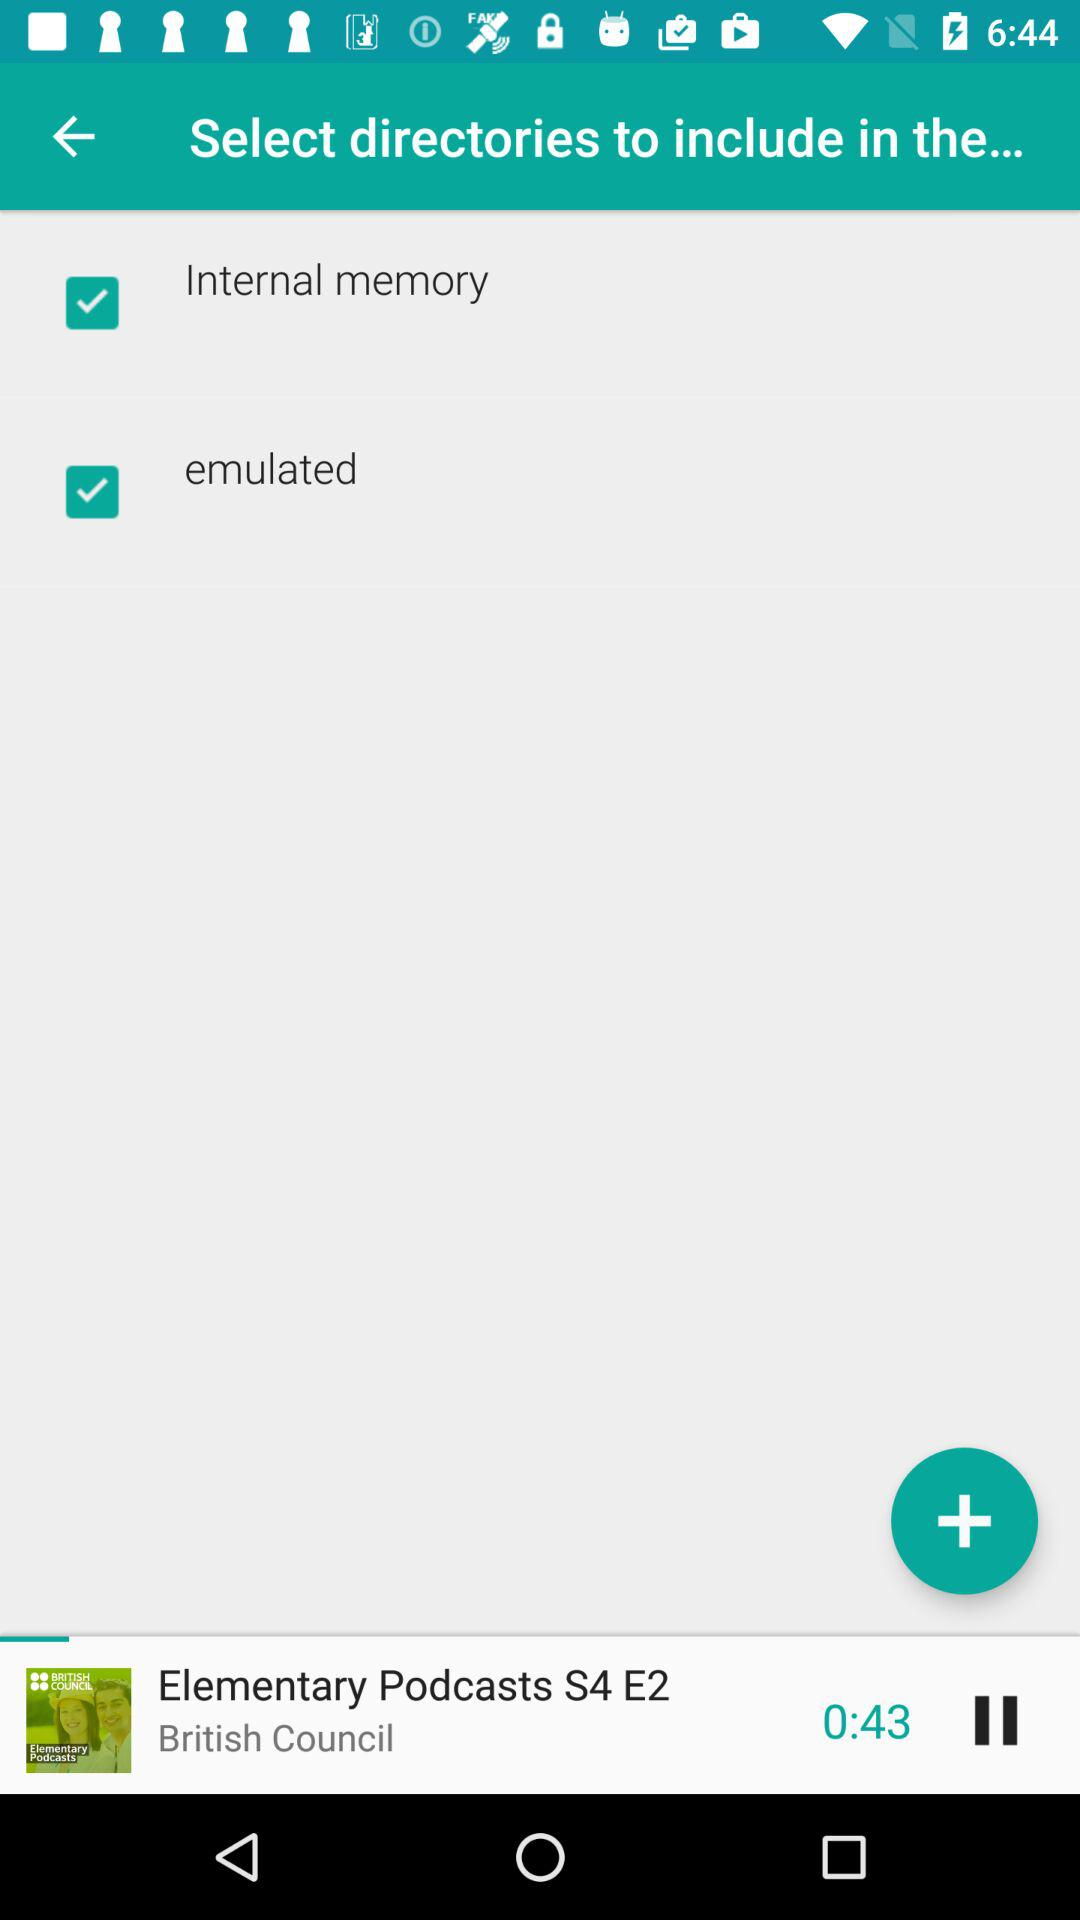What is the status of the "Internal memory"? The status of the "Internal memory" is "on". 